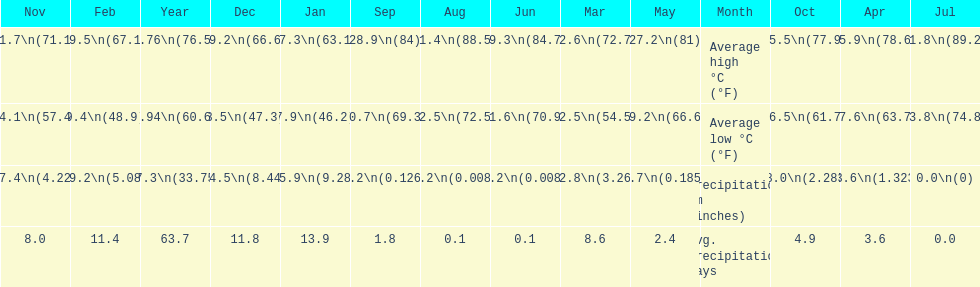I'm looking to parse the entire table for insights. Could you assist me with that? {'header': ['Nov', 'Feb', 'Year', 'Dec', 'Jan', 'Sep', 'Aug', 'Jun', 'Mar', 'May', 'Month', 'Oct', 'Apr', 'Jul'], 'rows': [['21.7\\n(71.1)', '19.5\\n(67.1)', '24.76\\n(76.57)', '19.2\\n(66.6)', '17.3\\n(63.1)', '28.9\\n(84)', '31.4\\n(88.5)', '29.3\\n(84.7)', '22.6\\n(72.7)', '27.2\\n(81)', 'Average high °C (°F)', '25.5\\n(77.9)', '25.9\\n(78.6)', '31.8\\n(89.2)'], ['14.1\\n(57.4)', '9.4\\n(48.9)', '15.94\\n(60.69)', '8.5\\n(47.3)', '7.9\\n(46.2)', '20.7\\n(69.3)', '22.5\\n(72.5)', '21.6\\n(70.9)', '12.5\\n(54.5)', '19.2\\n(66.6)', 'Average low °C (°F)', '16.5\\n(61.7)', '17.6\\n(63.7)', '23.8\\n(74.8)'], ['107.4\\n(4.228)', '129.2\\n(5.087)', '857.3\\n(33.752)', '214.5\\n(8.445)', '235.9\\n(9.287)', '3.2\\n(0.126)', '0.2\\n(0.008)', '0.2\\n(0.008)', '82.8\\n(3.26)', '4.7\\n(0.185)', 'Precipitation mm (inches)', '58.0\\n(2.283)', '33.6\\n(1.323)', '0.0\\n(0)'], ['8.0', '11.4', '63.7', '11.8', '13.9', '1.8', '0.1', '0.1', '8.6', '2.4', 'Avg. precipitation days', '4.9', '3.6', '0.0']]} Which month held the most precipitation? January. 